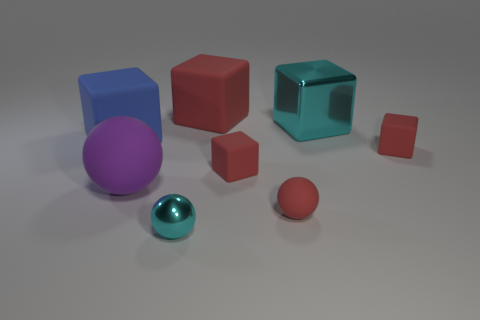Subtract all rubber spheres. How many spheres are left? 1 Subtract all spheres. How many objects are left? 5 Subtract all red blocks. How many blocks are left? 2 Subtract all red balls. Subtract all yellow blocks. How many balls are left? 2 Subtract all gray spheres. How many blue blocks are left? 1 Subtract all green rubber balls. Subtract all large rubber blocks. How many objects are left? 6 Add 3 matte objects. How many matte objects are left? 9 Add 8 small spheres. How many small spheres exist? 10 Add 1 matte things. How many objects exist? 9 Subtract 0 blue cylinders. How many objects are left? 8 